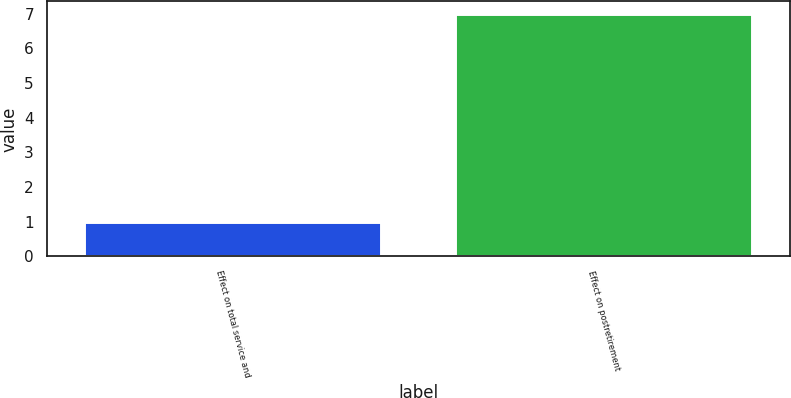<chart> <loc_0><loc_0><loc_500><loc_500><bar_chart><fcel>Effect on total service and<fcel>Effect on postretirement<nl><fcel>1<fcel>7<nl></chart> 